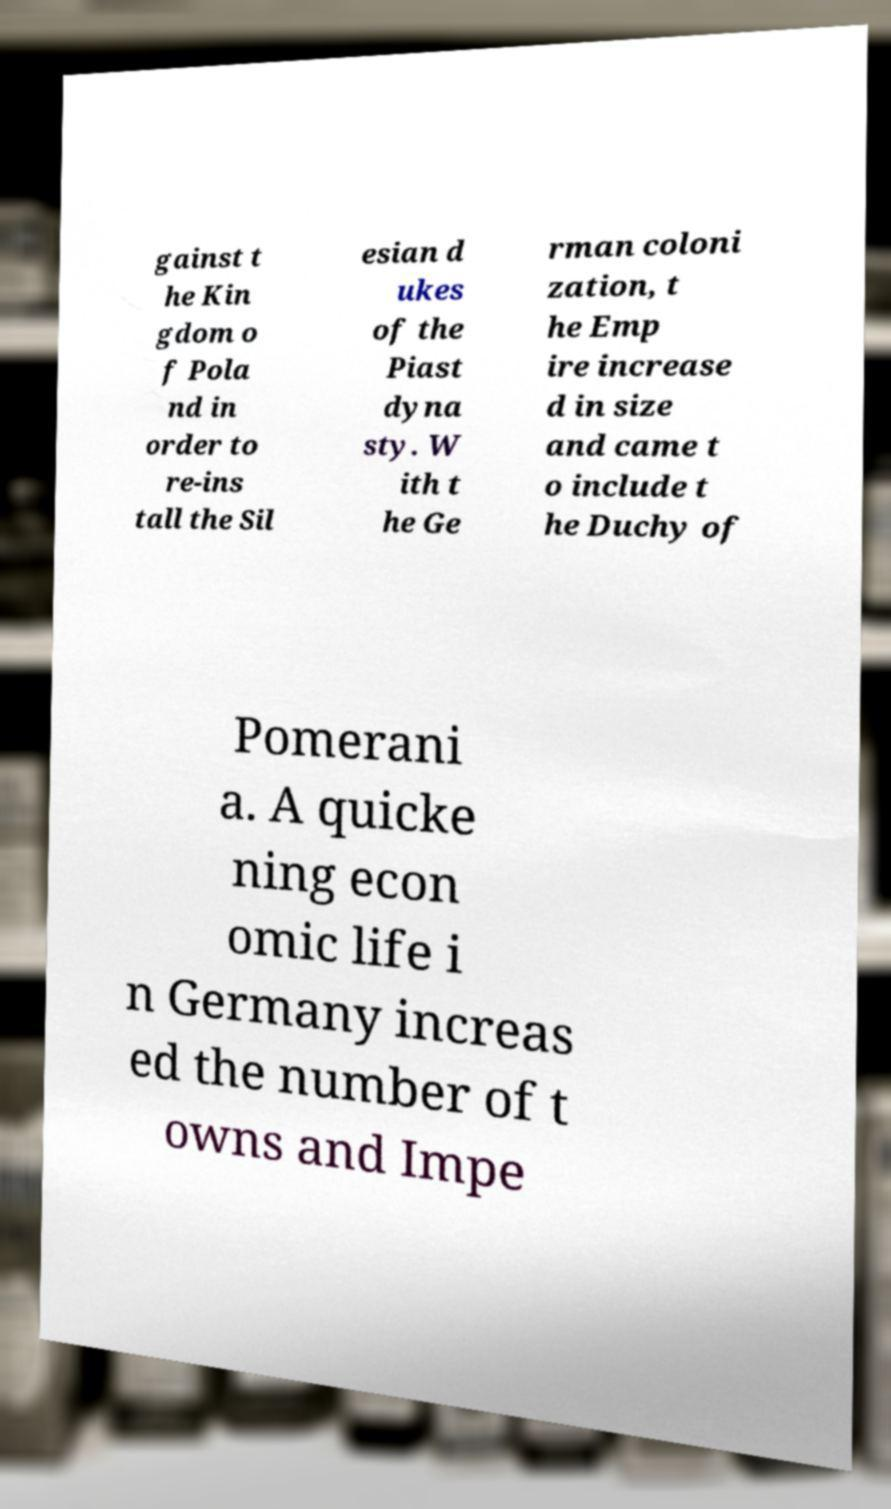Please identify and transcribe the text found in this image. gainst t he Kin gdom o f Pola nd in order to re-ins tall the Sil esian d ukes of the Piast dyna sty. W ith t he Ge rman coloni zation, t he Emp ire increase d in size and came t o include t he Duchy of Pomerani a. A quicke ning econ omic life i n Germany increas ed the number of t owns and Impe 